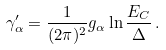<formula> <loc_0><loc_0><loc_500><loc_500>\gamma ^ { \prime } _ { \alpha } = \frac { 1 } { ( 2 \pi ) ^ { 2 } } g _ { \alpha } \ln \frac { E _ { C } } { \Delta } \, .</formula> 